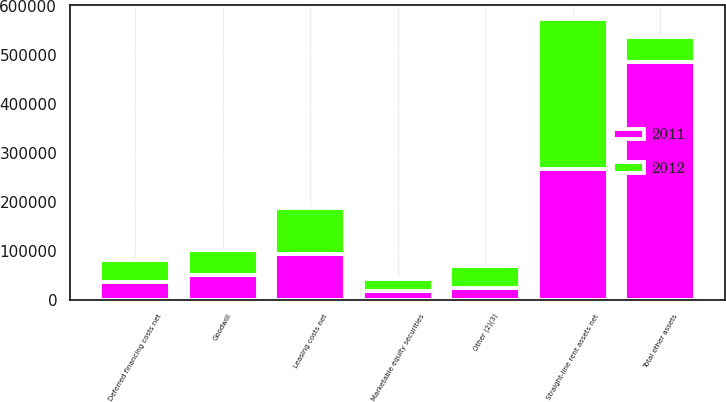Convert chart. <chart><loc_0><loc_0><loc_500><loc_500><stacked_bar_chart><ecel><fcel>Straight-line rent assets net<fcel>Leasing costs net<fcel>Deferred financing costs net<fcel>Goodwill<fcel>Marketable equity securities<fcel>Other (2)(3)<fcel>Total other assets<nl><fcel>2012<fcel>306294<fcel>93763<fcel>45490<fcel>50346<fcel>24829<fcel>44989<fcel>50346<nl><fcel>2011<fcel>266620<fcel>92288<fcel>35649<fcel>50346<fcel>17053<fcel>23502<fcel>485458<nl></chart> 